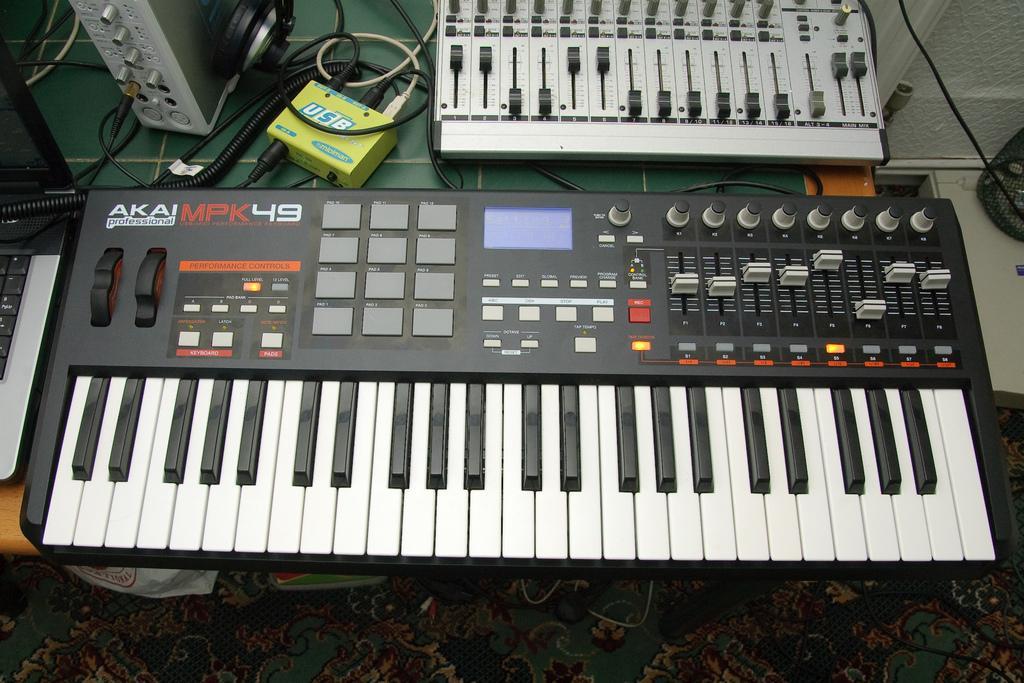Could you give a brief overview of what you see in this image? This is a zoomed in picture. In the foreground we can see a musical keyboard, cables and some machines is placed on the top of the green color table. In the background there are some objects. 